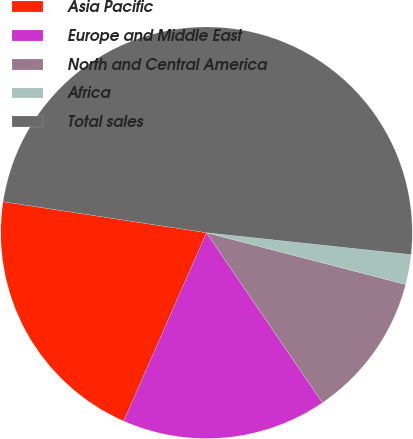<chart> <loc_0><loc_0><loc_500><loc_500><pie_chart><fcel>Asia Pacific<fcel>Europe and Middle East<fcel>North and Central America<fcel>Africa<fcel>Total sales<nl><fcel>20.81%<fcel>16.12%<fcel>11.43%<fcel>2.35%<fcel>49.28%<nl></chart> 